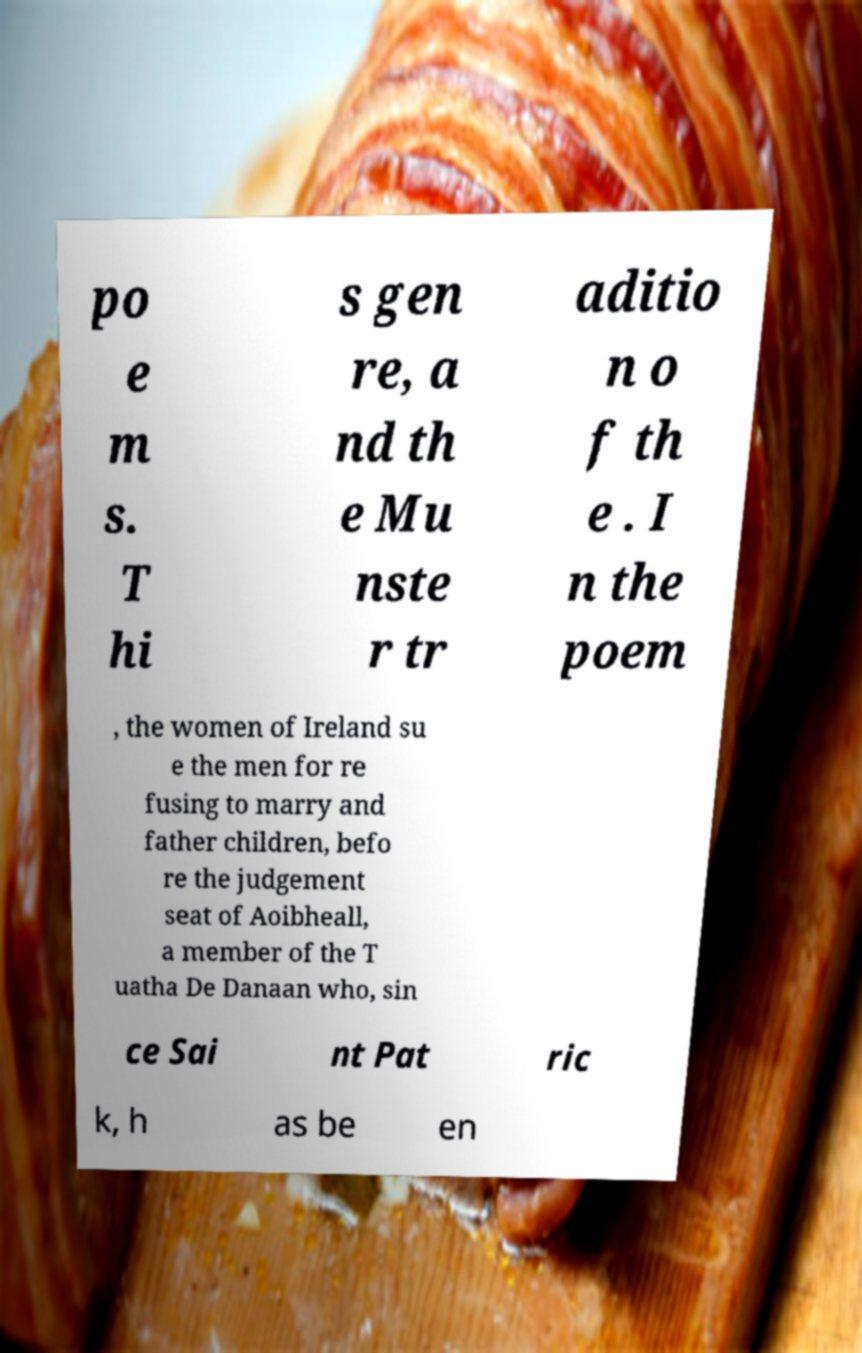There's text embedded in this image that I need extracted. Can you transcribe it verbatim? po e m s. T hi s gen re, a nd th e Mu nste r tr aditio n o f th e . I n the poem , the women of Ireland su e the men for re fusing to marry and father children, befo re the judgement seat of Aoibheall, a member of the T uatha De Danaan who, sin ce Sai nt Pat ric k, h as be en 